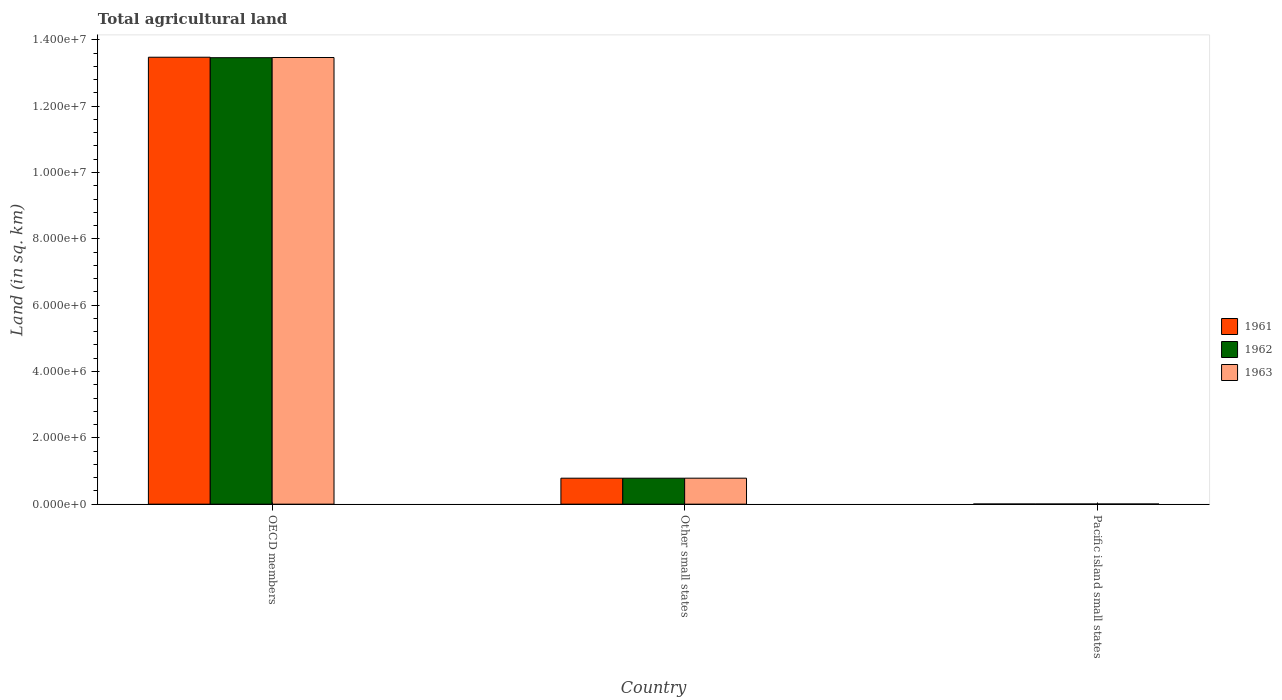How many groups of bars are there?
Give a very brief answer. 3. How many bars are there on the 1st tick from the left?
Provide a short and direct response. 3. What is the label of the 2nd group of bars from the left?
Give a very brief answer. Other small states. In how many cases, is the number of bars for a given country not equal to the number of legend labels?
Make the answer very short. 0. What is the total agricultural land in 1962 in OECD members?
Offer a terse response. 1.35e+07. Across all countries, what is the maximum total agricultural land in 1963?
Ensure brevity in your answer.  1.35e+07. Across all countries, what is the minimum total agricultural land in 1962?
Your answer should be compact. 5130. In which country was the total agricultural land in 1961 maximum?
Provide a succinct answer. OECD members. In which country was the total agricultural land in 1961 minimum?
Make the answer very short. Pacific island small states. What is the total total agricultural land in 1961 in the graph?
Give a very brief answer. 1.43e+07. What is the difference between the total agricultural land in 1961 in OECD members and that in Pacific island small states?
Your answer should be very brief. 1.35e+07. What is the difference between the total agricultural land in 1962 in OECD members and the total agricultural land in 1961 in Other small states?
Your answer should be compact. 1.27e+07. What is the average total agricultural land in 1961 per country?
Offer a very short reply. 4.75e+06. What is the ratio of the total agricultural land in 1961 in Other small states to that in Pacific island small states?
Give a very brief answer. 153.19. What is the difference between the highest and the second highest total agricultural land in 1961?
Your answer should be compact. -7.78e+05. What is the difference between the highest and the lowest total agricultural land in 1962?
Your answer should be compact. 1.35e+07. In how many countries, is the total agricultural land in 1961 greater than the average total agricultural land in 1961 taken over all countries?
Give a very brief answer. 1. What does the 2nd bar from the left in Other small states represents?
Your answer should be compact. 1962. How many bars are there?
Your answer should be very brief. 9. Are all the bars in the graph horizontal?
Your response must be concise. No. What is the difference between two consecutive major ticks on the Y-axis?
Offer a terse response. 2.00e+06. Are the values on the major ticks of Y-axis written in scientific E-notation?
Provide a short and direct response. Yes. Does the graph contain any zero values?
Your answer should be very brief. No. How many legend labels are there?
Keep it short and to the point. 3. What is the title of the graph?
Your response must be concise. Total agricultural land. What is the label or title of the Y-axis?
Your answer should be very brief. Land (in sq. km). What is the Land (in sq. km) of 1961 in OECD members?
Your answer should be compact. 1.35e+07. What is the Land (in sq. km) of 1962 in OECD members?
Your answer should be very brief. 1.35e+07. What is the Land (in sq. km) in 1963 in OECD members?
Give a very brief answer. 1.35e+07. What is the Land (in sq. km) of 1961 in Other small states?
Offer a terse response. 7.83e+05. What is the Land (in sq. km) of 1962 in Other small states?
Your answer should be compact. 7.83e+05. What is the Land (in sq. km) of 1963 in Other small states?
Offer a terse response. 7.83e+05. What is the Land (in sq. km) in 1961 in Pacific island small states?
Give a very brief answer. 5110. What is the Land (in sq. km) in 1962 in Pacific island small states?
Your answer should be compact. 5130. What is the Land (in sq. km) of 1963 in Pacific island small states?
Keep it short and to the point. 5190. Across all countries, what is the maximum Land (in sq. km) of 1961?
Your response must be concise. 1.35e+07. Across all countries, what is the maximum Land (in sq. km) in 1962?
Ensure brevity in your answer.  1.35e+07. Across all countries, what is the maximum Land (in sq. km) of 1963?
Your answer should be very brief. 1.35e+07. Across all countries, what is the minimum Land (in sq. km) in 1961?
Your response must be concise. 5110. Across all countries, what is the minimum Land (in sq. km) in 1962?
Offer a terse response. 5130. Across all countries, what is the minimum Land (in sq. km) of 1963?
Provide a succinct answer. 5190. What is the total Land (in sq. km) of 1961 in the graph?
Your response must be concise. 1.43e+07. What is the total Land (in sq. km) in 1962 in the graph?
Offer a very short reply. 1.42e+07. What is the total Land (in sq. km) of 1963 in the graph?
Provide a short and direct response. 1.43e+07. What is the difference between the Land (in sq. km) in 1961 in OECD members and that in Other small states?
Provide a short and direct response. 1.27e+07. What is the difference between the Land (in sq. km) in 1962 in OECD members and that in Other small states?
Your answer should be very brief. 1.27e+07. What is the difference between the Land (in sq. km) in 1963 in OECD members and that in Other small states?
Keep it short and to the point. 1.27e+07. What is the difference between the Land (in sq. km) of 1961 in OECD members and that in Pacific island small states?
Your answer should be very brief. 1.35e+07. What is the difference between the Land (in sq. km) in 1962 in OECD members and that in Pacific island small states?
Offer a very short reply. 1.35e+07. What is the difference between the Land (in sq. km) in 1963 in OECD members and that in Pacific island small states?
Ensure brevity in your answer.  1.35e+07. What is the difference between the Land (in sq. km) of 1961 in Other small states and that in Pacific island small states?
Give a very brief answer. 7.78e+05. What is the difference between the Land (in sq. km) of 1962 in Other small states and that in Pacific island small states?
Provide a short and direct response. 7.78e+05. What is the difference between the Land (in sq. km) in 1963 in Other small states and that in Pacific island small states?
Offer a very short reply. 7.78e+05. What is the difference between the Land (in sq. km) in 1961 in OECD members and the Land (in sq. km) in 1962 in Other small states?
Give a very brief answer. 1.27e+07. What is the difference between the Land (in sq. km) of 1961 in OECD members and the Land (in sq. km) of 1963 in Other small states?
Your answer should be compact. 1.27e+07. What is the difference between the Land (in sq. km) in 1962 in OECD members and the Land (in sq. km) in 1963 in Other small states?
Your answer should be very brief. 1.27e+07. What is the difference between the Land (in sq. km) in 1961 in OECD members and the Land (in sq. km) in 1962 in Pacific island small states?
Offer a terse response. 1.35e+07. What is the difference between the Land (in sq. km) of 1961 in OECD members and the Land (in sq. km) of 1963 in Pacific island small states?
Offer a terse response. 1.35e+07. What is the difference between the Land (in sq. km) in 1962 in OECD members and the Land (in sq. km) in 1963 in Pacific island small states?
Provide a succinct answer. 1.35e+07. What is the difference between the Land (in sq. km) of 1961 in Other small states and the Land (in sq. km) of 1962 in Pacific island small states?
Give a very brief answer. 7.78e+05. What is the difference between the Land (in sq. km) in 1961 in Other small states and the Land (in sq. km) in 1963 in Pacific island small states?
Make the answer very short. 7.78e+05. What is the difference between the Land (in sq. km) in 1962 in Other small states and the Land (in sq. km) in 1963 in Pacific island small states?
Ensure brevity in your answer.  7.78e+05. What is the average Land (in sq. km) of 1961 per country?
Provide a short and direct response. 4.75e+06. What is the average Land (in sq. km) in 1962 per country?
Your response must be concise. 4.75e+06. What is the average Land (in sq. km) of 1963 per country?
Your response must be concise. 4.75e+06. What is the difference between the Land (in sq. km) of 1961 and Land (in sq. km) of 1962 in OECD members?
Provide a short and direct response. 1.42e+04. What is the difference between the Land (in sq. km) in 1961 and Land (in sq. km) in 1963 in OECD members?
Give a very brief answer. 8693. What is the difference between the Land (in sq. km) in 1962 and Land (in sq. km) in 1963 in OECD members?
Offer a very short reply. -5492. What is the difference between the Land (in sq. km) of 1961 and Land (in sq. km) of 1962 in Other small states?
Ensure brevity in your answer.  -290. What is the difference between the Land (in sq. km) of 1961 and Land (in sq. km) of 1963 in Other small states?
Ensure brevity in your answer.  -460. What is the difference between the Land (in sq. km) of 1962 and Land (in sq. km) of 1963 in Other small states?
Your answer should be compact. -170. What is the difference between the Land (in sq. km) of 1961 and Land (in sq. km) of 1963 in Pacific island small states?
Give a very brief answer. -80. What is the difference between the Land (in sq. km) of 1962 and Land (in sq. km) of 1963 in Pacific island small states?
Provide a succinct answer. -60. What is the ratio of the Land (in sq. km) in 1961 in OECD members to that in Other small states?
Provide a short and direct response. 17.21. What is the ratio of the Land (in sq. km) in 1962 in OECD members to that in Other small states?
Keep it short and to the point. 17.19. What is the ratio of the Land (in sq. km) in 1963 in OECD members to that in Other small states?
Make the answer very short. 17.19. What is the ratio of the Land (in sq. km) of 1961 in OECD members to that in Pacific island small states?
Make the answer very short. 2637.03. What is the ratio of the Land (in sq. km) of 1962 in OECD members to that in Pacific island small states?
Your answer should be compact. 2623.99. What is the ratio of the Land (in sq. km) of 1963 in OECD members to that in Pacific island small states?
Keep it short and to the point. 2594.71. What is the ratio of the Land (in sq. km) in 1961 in Other small states to that in Pacific island small states?
Provide a succinct answer. 153.19. What is the ratio of the Land (in sq. km) in 1962 in Other small states to that in Pacific island small states?
Give a very brief answer. 152.65. What is the ratio of the Land (in sq. km) in 1963 in Other small states to that in Pacific island small states?
Offer a very short reply. 150.91. What is the difference between the highest and the second highest Land (in sq. km) in 1961?
Your answer should be very brief. 1.27e+07. What is the difference between the highest and the second highest Land (in sq. km) of 1962?
Offer a terse response. 1.27e+07. What is the difference between the highest and the second highest Land (in sq. km) of 1963?
Give a very brief answer. 1.27e+07. What is the difference between the highest and the lowest Land (in sq. km) in 1961?
Provide a short and direct response. 1.35e+07. What is the difference between the highest and the lowest Land (in sq. km) in 1962?
Your answer should be very brief. 1.35e+07. What is the difference between the highest and the lowest Land (in sq. km) of 1963?
Your response must be concise. 1.35e+07. 